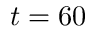Convert formula to latex. <formula><loc_0><loc_0><loc_500><loc_500>t = 6 0</formula> 